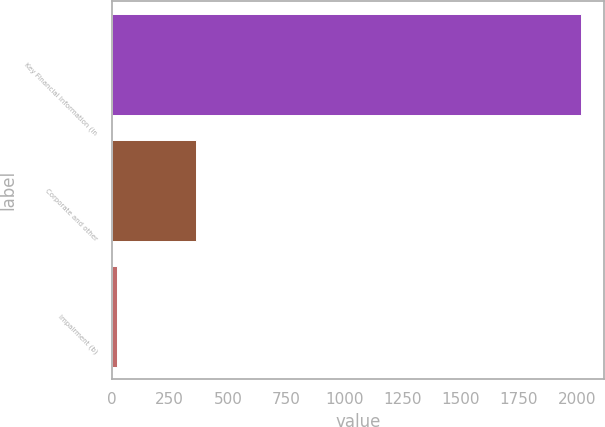<chart> <loc_0><loc_0><loc_500><loc_500><bar_chart><fcel>Key Financial Information (in<fcel>Corporate and other<fcel>Impairment (b)<nl><fcel>2017<fcel>365<fcel>23<nl></chart> 